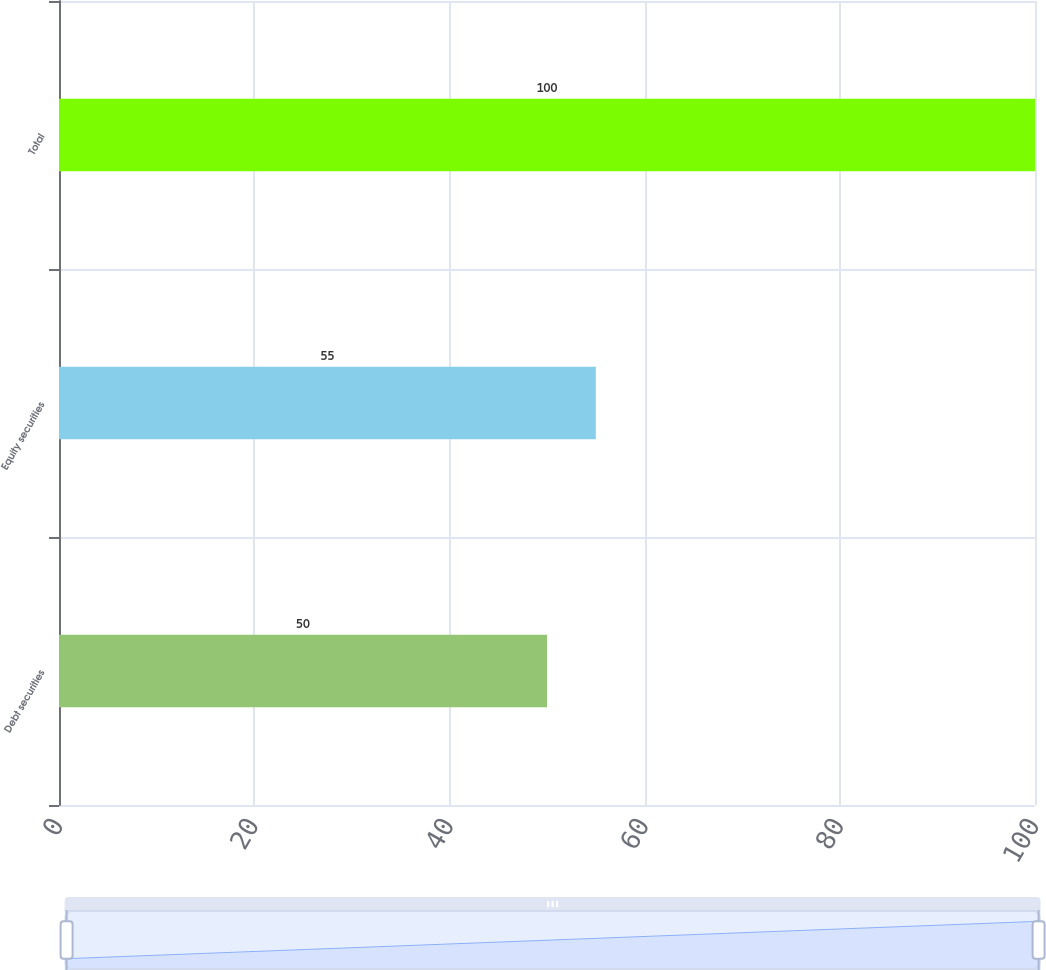Convert chart to OTSL. <chart><loc_0><loc_0><loc_500><loc_500><bar_chart><fcel>Debt securities<fcel>Equity securities<fcel>Total<nl><fcel>50<fcel>55<fcel>100<nl></chart> 